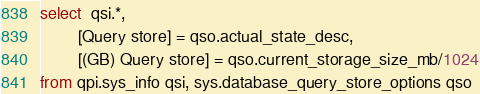<code> <loc_0><loc_0><loc_500><loc_500><_SQL_>select  qsi.*,
        [Query store] = qso.actual_state_desc,
        [(GB) Query store] = qso.current_storage_size_mb/1024
from qpi.sys_info qsi, sys.database_query_store_options qso</code> 